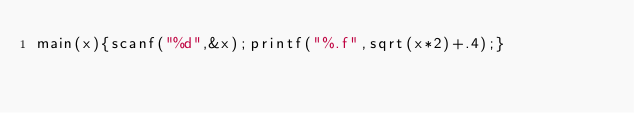Convert code to text. <code><loc_0><loc_0><loc_500><loc_500><_C_>main(x){scanf("%d",&x);printf("%.f",sqrt(x*2)+.4);}</code> 